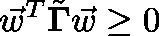<formula> <loc_0><loc_0><loc_500><loc_500>\vec { w } ^ { T } \tilde { \Gamma } \vec { w } \geq 0</formula> 